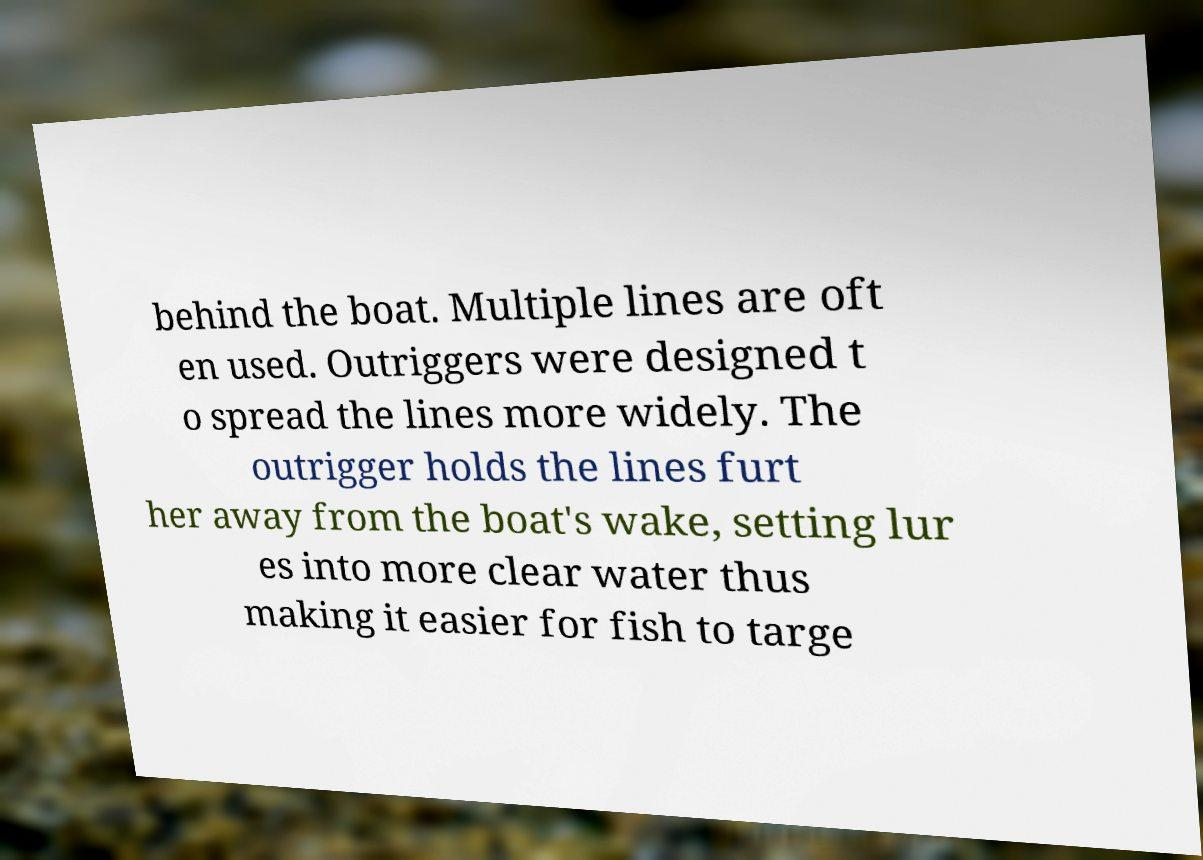For documentation purposes, I need the text within this image transcribed. Could you provide that? behind the boat. Multiple lines are oft en used. Outriggers were designed t o spread the lines more widely. The outrigger holds the lines furt her away from the boat's wake, setting lur es into more clear water thus making it easier for fish to targe 